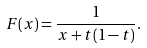Convert formula to latex. <formula><loc_0><loc_0><loc_500><loc_500>F ( x ) = \frac { 1 } { x + t ( 1 - t ) } .</formula> 